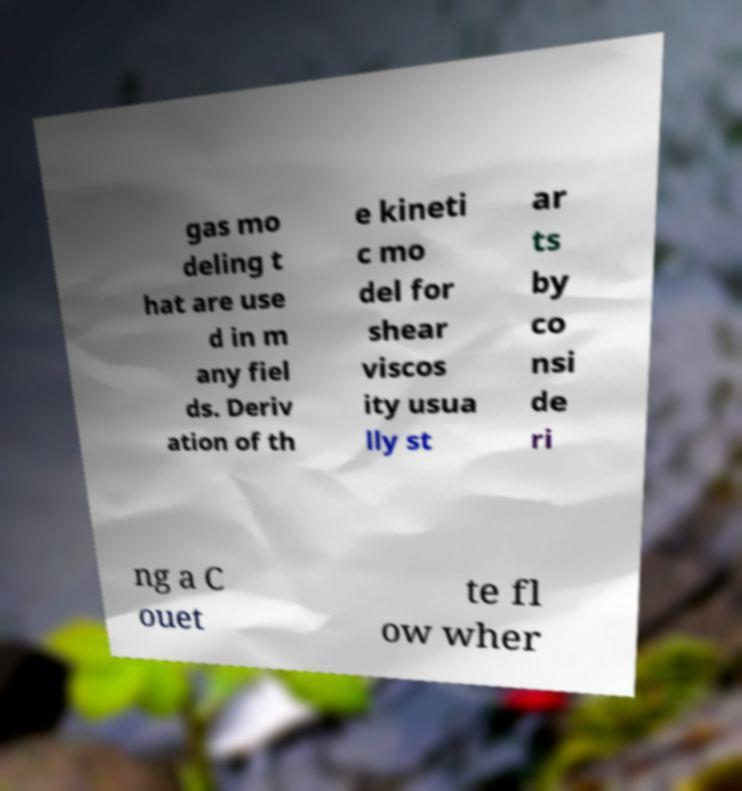Can you read and provide the text displayed in the image?This photo seems to have some interesting text. Can you extract and type it out for me? gas mo deling t hat are use d in m any fiel ds. Deriv ation of th e kineti c mo del for shear viscos ity usua lly st ar ts by co nsi de ri ng a C ouet te fl ow wher 